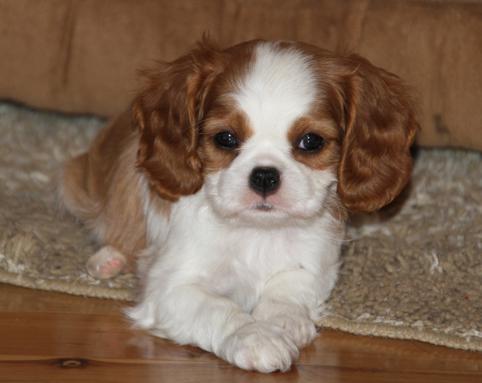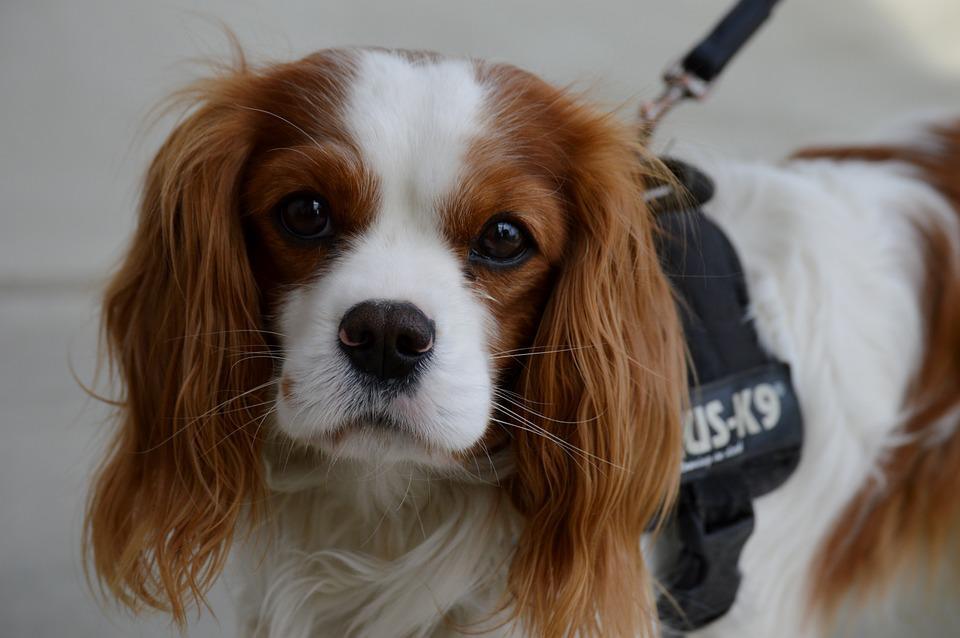The first image is the image on the left, the second image is the image on the right. Evaluate the accuracy of this statement regarding the images: "A dog is lying on the floor with its head up in the left image.". Is it true? Answer yes or no. Yes. The first image is the image on the left, the second image is the image on the right. For the images shown, is this caption "An image shows one brown and white dog posed on a brownish tile floor." true? Answer yes or no. No. 